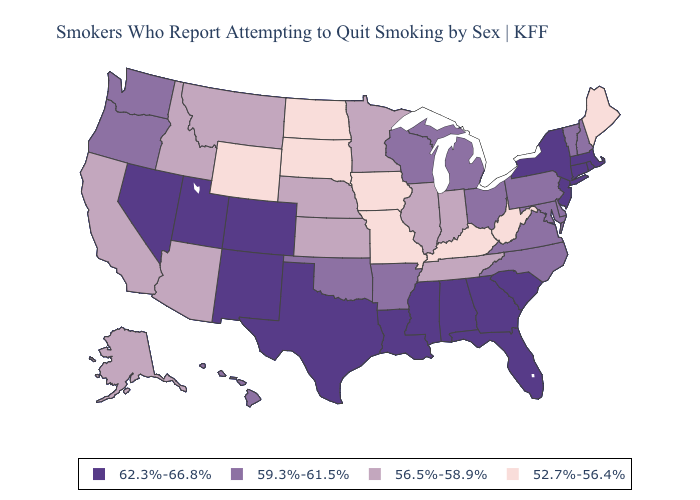Among the states that border Missouri , which have the lowest value?
Short answer required. Iowa, Kentucky. Name the states that have a value in the range 62.3%-66.8%?
Short answer required. Alabama, Colorado, Connecticut, Florida, Georgia, Louisiana, Massachusetts, Mississippi, Nevada, New Jersey, New Mexico, New York, Rhode Island, South Carolina, Texas, Utah. Does Hawaii have a higher value than Minnesota?
Give a very brief answer. Yes. Does Rhode Island have the lowest value in the Northeast?
Short answer required. No. What is the value of Kansas?
Keep it brief. 56.5%-58.9%. What is the value of Colorado?
Quick response, please. 62.3%-66.8%. Does Maryland have the same value as Indiana?
Write a very short answer. No. Which states have the highest value in the USA?
Write a very short answer. Alabama, Colorado, Connecticut, Florida, Georgia, Louisiana, Massachusetts, Mississippi, Nevada, New Jersey, New Mexico, New York, Rhode Island, South Carolina, Texas, Utah. Name the states that have a value in the range 52.7%-56.4%?
Quick response, please. Iowa, Kentucky, Maine, Missouri, North Dakota, South Dakota, West Virginia, Wyoming. What is the highest value in states that border Massachusetts?
Short answer required. 62.3%-66.8%. Name the states that have a value in the range 52.7%-56.4%?
Write a very short answer. Iowa, Kentucky, Maine, Missouri, North Dakota, South Dakota, West Virginia, Wyoming. What is the lowest value in the USA?
Quick response, please. 52.7%-56.4%. Does Hawaii have a lower value than Minnesota?
Concise answer only. No. Name the states that have a value in the range 52.7%-56.4%?
Quick response, please. Iowa, Kentucky, Maine, Missouri, North Dakota, South Dakota, West Virginia, Wyoming. Which states have the lowest value in the USA?
Write a very short answer. Iowa, Kentucky, Maine, Missouri, North Dakota, South Dakota, West Virginia, Wyoming. 